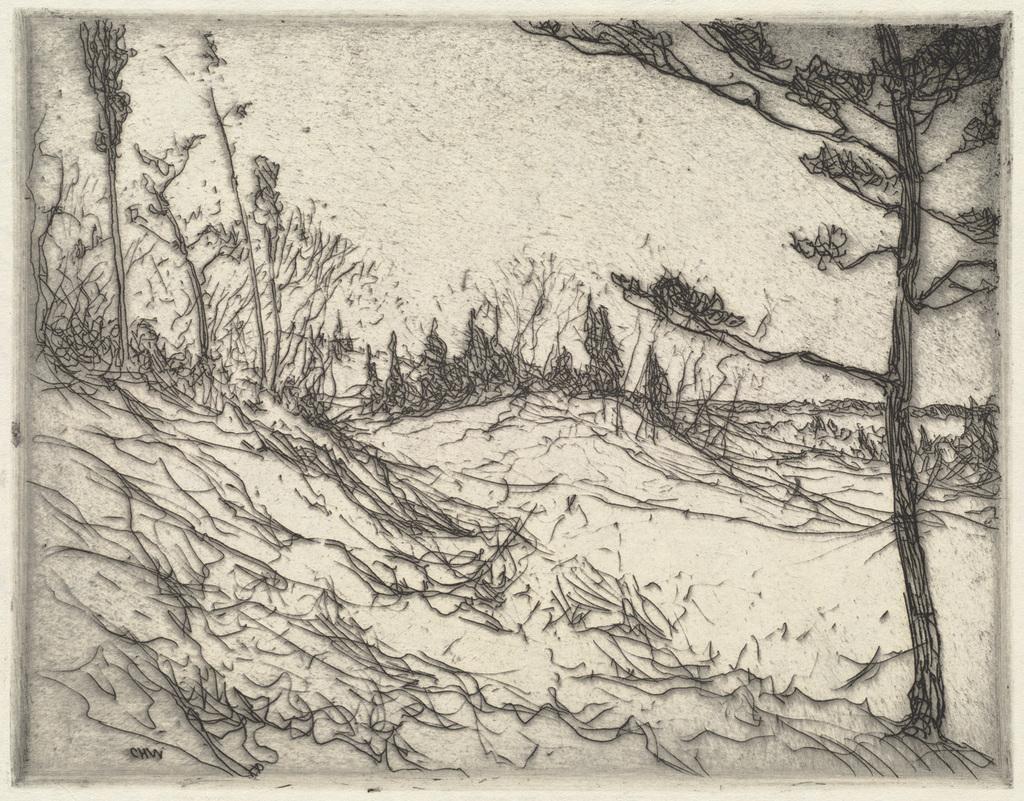Describe this image in one or two sentences. This is the drawing image where there are trees. 